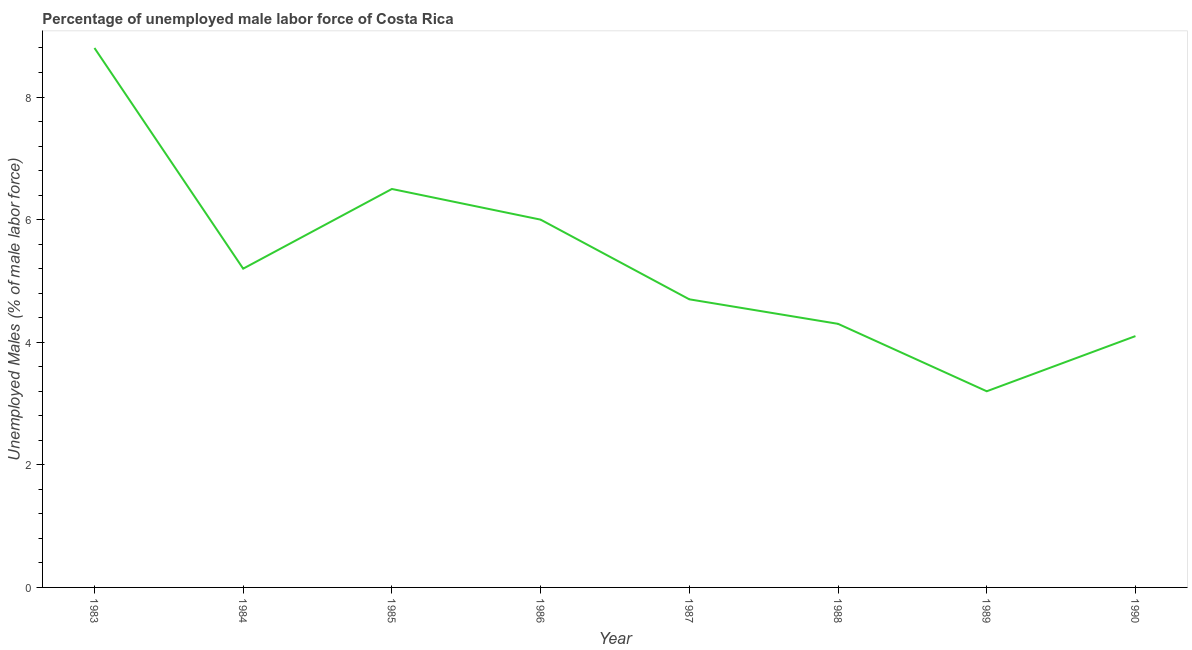What is the total unemployed male labour force in 1985?
Provide a succinct answer. 6.5. Across all years, what is the maximum total unemployed male labour force?
Your answer should be compact. 8.8. Across all years, what is the minimum total unemployed male labour force?
Provide a succinct answer. 3.2. In which year was the total unemployed male labour force minimum?
Make the answer very short. 1989. What is the sum of the total unemployed male labour force?
Your response must be concise. 42.8. What is the difference between the total unemployed male labour force in 1986 and 1988?
Make the answer very short. 1.7. What is the average total unemployed male labour force per year?
Your response must be concise. 5.35. What is the median total unemployed male labour force?
Provide a short and direct response. 4.95. Do a majority of the years between 1990 and 1985 (inclusive) have total unemployed male labour force greater than 2 %?
Keep it short and to the point. Yes. What is the ratio of the total unemployed male labour force in 1988 to that in 1990?
Provide a short and direct response. 1.05. Is the total unemployed male labour force in 1986 less than that in 1990?
Ensure brevity in your answer.  No. What is the difference between the highest and the second highest total unemployed male labour force?
Provide a succinct answer. 2.3. What is the difference between the highest and the lowest total unemployed male labour force?
Your answer should be compact. 5.6. Does the total unemployed male labour force monotonically increase over the years?
Give a very brief answer. No. How many lines are there?
Your answer should be very brief. 1. What is the difference between two consecutive major ticks on the Y-axis?
Keep it short and to the point. 2. What is the title of the graph?
Ensure brevity in your answer.  Percentage of unemployed male labor force of Costa Rica. What is the label or title of the Y-axis?
Your answer should be very brief. Unemployed Males (% of male labor force). What is the Unemployed Males (% of male labor force) of 1983?
Your answer should be very brief. 8.8. What is the Unemployed Males (% of male labor force) in 1984?
Provide a succinct answer. 5.2. What is the Unemployed Males (% of male labor force) in 1986?
Provide a short and direct response. 6. What is the Unemployed Males (% of male labor force) of 1987?
Your answer should be compact. 4.7. What is the Unemployed Males (% of male labor force) in 1988?
Offer a terse response. 4.3. What is the Unemployed Males (% of male labor force) of 1989?
Your answer should be compact. 3.2. What is the Unemployed Males (% of male labor force) of 1990?
Your answer should be very brief. 4.1. What is the difference between the Unemployed Males (% of male labor force) in 1983 and 1986?
Keep it short and to the point. 2.8. What is the difference between the Unemployed Males (% of male labor force) in 1983 and 1987?
Your answer should be very brief. 4.1. What is the difference between the Unemployed Males (% of male labor force) in 1983 and 1988?
Your response must be concise. 4.5. What is the difference between the Unemployed Males (% of male labor force) in 1983 and 1990?
Provide a short and direct response. 4.7. What is the difference between the Unemployed Males (% of male labor force) in 1984 and 1985?
Ensure brevity in your answer.  -1.3. What is the difference between the Unemployed Males (% of male labor force) in 1984 and 1988?
Your response must be concise. 0.9. What is the difference between the Unemployed Males (% of male labor force) in 1984 and 1990?
Make the answer very short. 1.1. What is the difference between the Unemployed Males (% of male labor force) in 1985 and 1990?
Provide a short and direct response. 2.4. What is the difference between the Unemployed Males (% of male labor force) in 1986 and 1988?
Make the answer very short. 1.7. What is the difference between the Unemployed Males (% of male labor force) in 1986 and 1990?
Make the answer very short. 1.9. What is the difference between the Unemployed Males (% of male labor force) in 1987 and 1989?
Keep it short and to the point. 1.5. What is the ratio of the Unemployed Males (% of male labor force) in 1983 to that in 1984?
Offer a very short reply. 1.69. What is the ratio of the Unemployed Males (% of male labor force) in 1983 to that in 1985?
Make the answer very short. 1.35. What is the ratio of the Unemployed Males (% of male labor force) in 1983 to that in 1986?
Offer a terse response. 1.47. What is the ratio of the Unemployed Males (% of male labor force) in 1983 to that in 1987?
Provide a short and direct response. 1.87. What is the ratio of the Unemployed Males (% of male labor force) in 1983 to that in 1988?
Your answer should be compact. 2.05. What is the ratio of the Unemployed Males (% of male labor force) in 1983 to that in 1989?
Make the answer very short. 2.75. What is the ratio of the Unemployed Males (% of male labor force) in 1983 to that in 1990?
Make the answer very short. 2.15. What is the ratio of the Unemployed Males (% of male labor force) in 1984 to that in 1986?
Provide a succinct answer. 0.87. What is the ratio of the Unemployed Males (% of male labor force) in 1984 to that in 1987?
Your answer should be very brief. 1.11. What is the ratio of the Unemployed Males (% of male labor force) in 1984 to that in 1988?
Offer a terse response. 1.21. What is the ratio of the Unemployed Males (% of male labor force) in 1984 to that in 1989?
Offer a very short reply. 1.62. What is the ratio of the Unemployed Males (% of male labor force) in 1984 to that in 1990?
Ensure brevity in your answer.  1.27. What is the ratio of the Unemployed Males (% of male labor force) in 1985 to that in 1986?
Provide a short and direct response. 1.08. What is the ratio of the Unemployed Males (% of male labor force) in 1985 to that in 1987?
Provide a succinct answer. 1.38. What is the ratio of the Unemployed Males (% of male labor force) in 1985 to that in 1988?
Offer a very short reply. 1.51. What is the ratio of the Unemployed Males (% of male labor force) in 1985 to that in 1989?
Make the answer very short. 2.03. What is the ratio of the Unemployed Males (% of male labor force) in 1985 to that in 1990?
Offer a terse response. 1.58. What is the ratio of the Unemployed Males (% of male labor force) in 1986 to that in 1987?
Give a very brief answer. 1.28. What is the ratio of the Unemployed Males (% of male labor force) in 1986 to that in 1988?
Make the answer very short. 1.4. What is the ratio of the Unemployed Males (% of male labor force) in 1986 to that in 1989?
Keep it short and to the point. 1.88. What is the ratio of the Unemployed Males (% of male labor force) in 1986 to that in 1990?
Give a very brief answer. 1.46. What is the ratio of the Unemployed Males (% of male labor force) in 1987 to that in 1988?
Your answer should be very brief. 1.09. What is the ratio of the Unemployed Males (% of male labor force) in 1987 to that in 1989?
Your answer should be very brief. 1.47. What is the ratio of the Unemployed Males (% of male labor force) in 1987 to that in 1990?
Provide a short and direct response. 1.15. What is the ratio of the Unemployed Males (% of male labor force) in 1988 to that in 1989?
Offer a very short reply. 1.34. What is the ratio of the Unemployed Males (% of male labor force) in 1988 to that in 1990?
Give a very brief answer. 1.05. What is the ratio of the Unemployed Males (% of male labor force) in 1989 to that in 1990?
Keep it short and to the point. 0.78. 